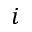Convert formula to latex. <formula><loc_0><loc_0><loc_500><loc_500>i</formula> 